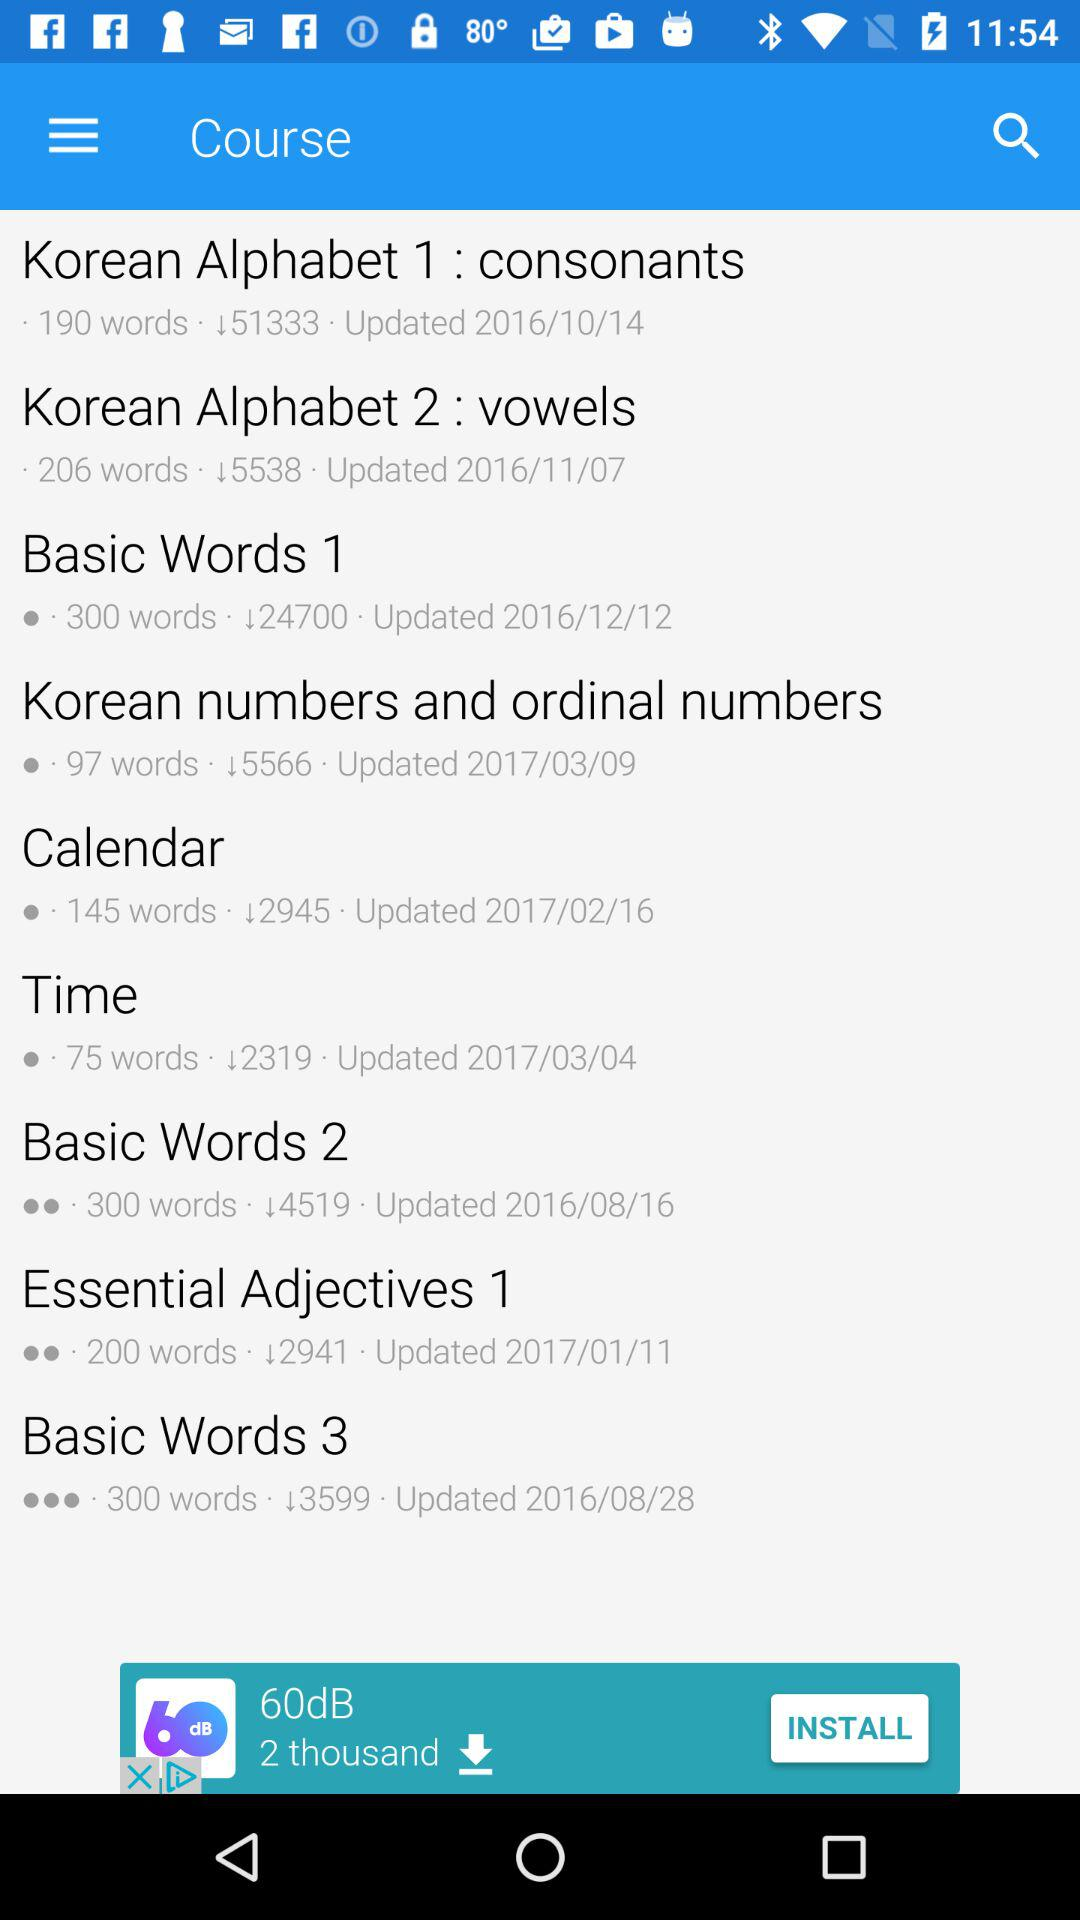What is the name of the course?
When the provided information is insufficient, respond with <no answer>. <no answer> 